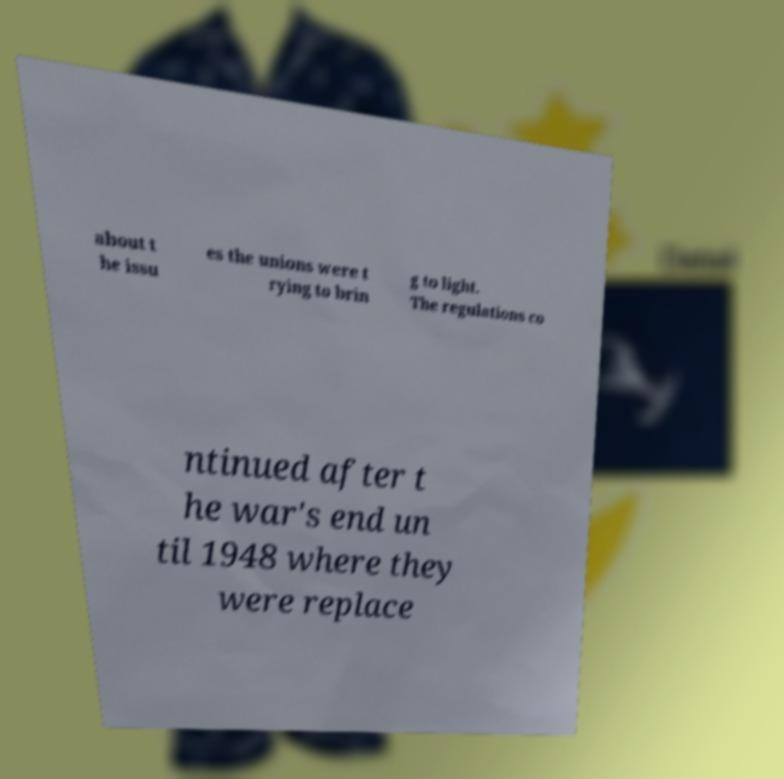For documentation purposes, I need the text within this image transcribed. Could you provide that? about t he issu es the unions were t rying to brin g to light. The regulations co ntinued after t he war's end un til 1948 where they were replace 